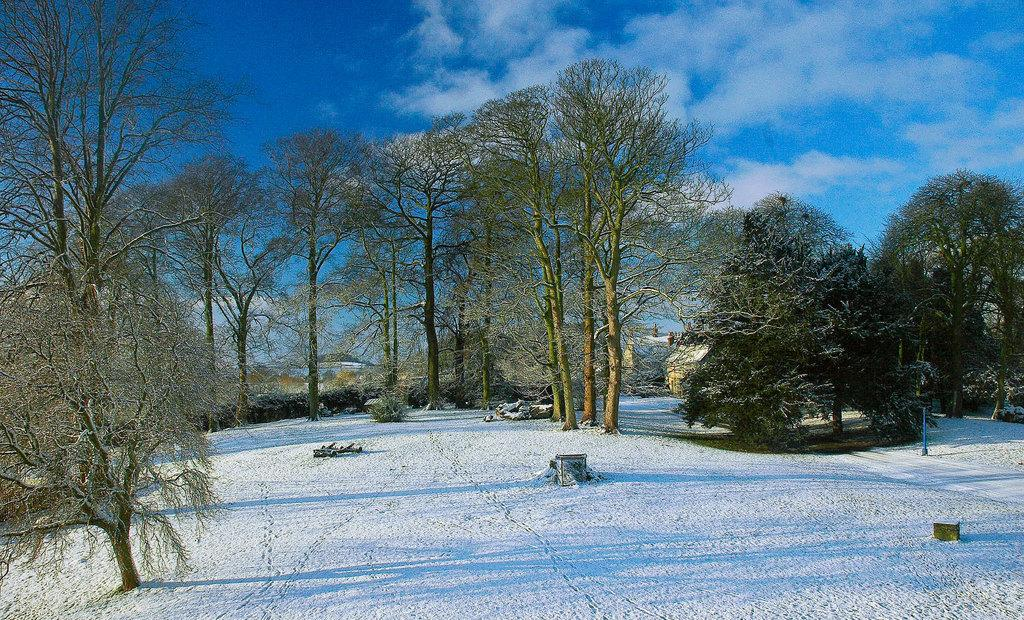What type of vegetation can be seen in the image? There are trees in the image. What is the condition of the land in the image? The land is covered with snow. What is visible in the sky in the image? The sky is visible in the image, and there are clouds present. Where is the playground located in the image? There is no playground present in the image. What direction is the wind blowing in the image? There is no indication of wind direction in the image. 